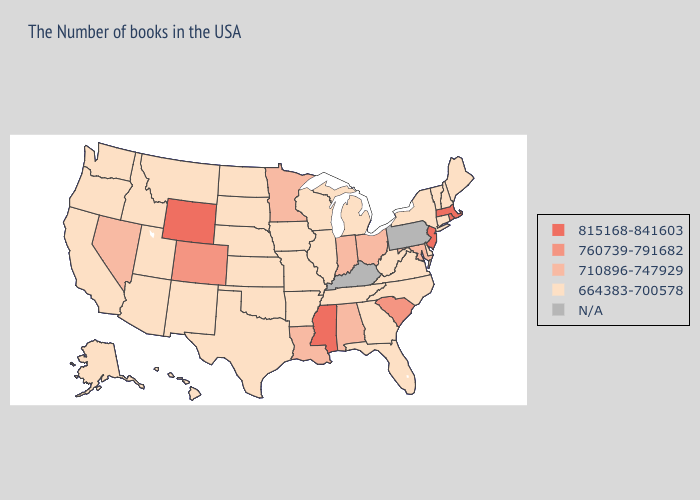Name the states that have a value in the range 710896-747929?
Short answer required. Maryland, Ohio, Indiana, Alabama, Louisiana, Minnesota, Nevada. What is the lowest value in states that border North Dakota?
Answer briefly. 664383-700578. Does Wisconsin have the highest value in the MidWest?
Give a very brief answer. No. What is the lowest value in states that border Mississippi?
Quick response, please. 664383-700578. Name the states that have a value in the range 664383-700578?
Concise answer only. Maine, New Hampshire, Vermont, Connecticut, New York, Delaware, Virginia, North Carolina, West Virginia, Florida, Georgia, Michigan, Tennessee, Wisconsin, Illinois, Missouri, Arkansas, Iowa, Kansas, Nebraska, Oklahoma, Texas, South Dakota, North Dakota, New Mexico, Utah, Montana, Arizona, Idaho, California, Washington, Oregon, Alaska, Hawaii. What is the highest value in the USA?
Give a very brief answer. 815168-841603. Which states have the lowest value in the West?
Answer briefly. New Mexico, Utah, Montana, Arizona, Idaho, California, Washington, Oregon, Alaska, Hawaii. What is the value of Montana?
Give a very brief answer. 664383-700578. Among the states that border Kansas , which have the lowest value?
Write a very short answer. Missouri, Nebraska, Oklahoma. Name the states that have a value in the range N/A?
Keep it brief. Pennsylvania, Kentucky. Does Mississippi have the highest value in the USA?
Give a very brief answer. Yes. Which states have the lowest value in the USA?
Keep it brief. Maine, New Hampshire, Vermont, Connecticut, New York, Delaware, Virginia, North Carolina, West Virginia, Florida, Georgia, Michigan, Tennessee, Wisconsin, Illinois, Missouri, Arkansas, Iowa, Kansas, Nebraska, Oklahoma, Texas, South Dakota, North Dakota, New Mexico, Utah, Montana, Arizona, Idaho, California, Washington, Oregon, Alaska, Hawaii. Name the states that have a value in the range N/A?
Quick response, please. Pennsylvania, Kentucky. 